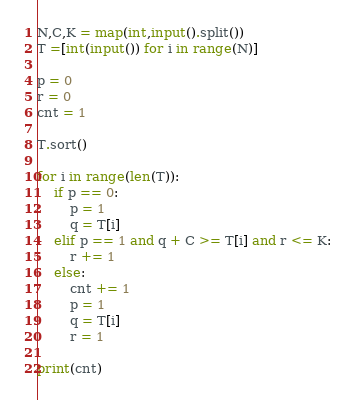<code> <loc_0><loc_0><loc_500><loc_500><_Python_>N,C,K = map(int,input().split())
T =[int(input()) for i in range(N)]

p = 0
r = 0
cnt = 1

T.sort()

for i in range(len(T)):
    if p == 0:
        p = 1
        q = T[i]
    elif p == 1 and q + C >= T[i] and r <= K:
        r += 1
    else:
        cnt += 1
        p = 1
        q = T[i]
        r = 1

print(cnt)
</code> 